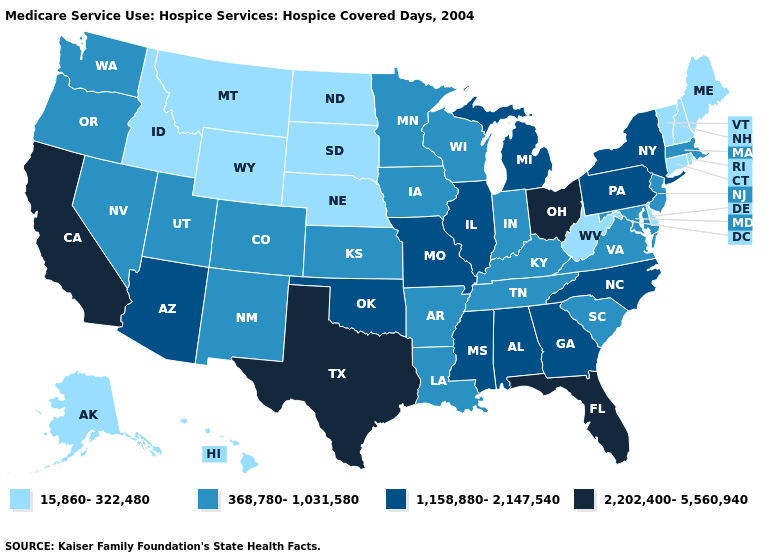What is the lowest value in the South?
Concise answer only. 15,860-322,480. Does Hawaii have the lowest value in the West?
Answer briefly. Yes. Does California have the highest value in the West?
Be succinct. Yes. What is the lowest value in the USA?
Give a very brief answer. 15,860-322,480. What is the value of Hawaii?
Concise answer only. 15,860-322,480. Among the states that border New Hampshire , does Maine have the highest value?
Concise answer only. No. What is the value of Tennessee?
Keep it brief. 368,780-1,031,580. What is the highest value in states that border Rhode Island?
Be succinct. 368,780-1,031,580. Name the states that have a value in the range 368,780-1,031,580?
Write a very short answer. Arkansas, Colorado, Indiana, Iowa, Kansas, Kentucky, Louisiana, Maryland, Massachusetts, Minnesota, Nevada, New Jersey, New Mexico, Oregon, South Carolina, Tennessee, Utah, Virginia, Washington, Wisconsin. What is the lowest value in the USA?
Be succinct. 15,860-322,480. Among the states that border Kansas , does Oklahoma have the highest value?
Write a very short answer. Yes. How many symbols are there in the legend?
Keep it brief. 4. Name the states that have a value in the range 1,158,880-2,147,540?
Quick response, please. Alabama, Arizona, Georgia, Illinois, Michigan, Mississippi, Missouri, New York, North Carolina, Oklahoma, Pennsylvania. What is the value of Missouri?
Short answer required. 1,158,880-2,147,540. Name the states that have a value in the range 2,202,400-5,560,940?
Short answer required. California, Florida, Ohio, Texas. 